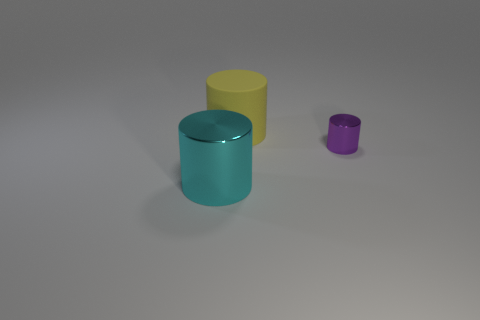Add 3 small shiny things. How many objects exist? 6 Subtract all small purple cylinders. How many cylinders are left? 2 Subtract 2 cylinders. How many cylinders are left? 1 Subtract all red cylinders. Subtract all gray balls. How many cylinders are left? 3 Subtract all purple cubes. How many purple cylinders are left? 1 Subtract all brown rubber objects. Subtract all tiny metallic cylinders. How many objects are left? 2 Add 2 big yellow cylinders. How many big yellow cylinders are left? 3 Add 3 big blue objects. How many big blue objects exist? 3 Subtract all purple cylinders. How many cylinders are left? 2 Subtract 0 cyan balls. How many objects are left? 3 